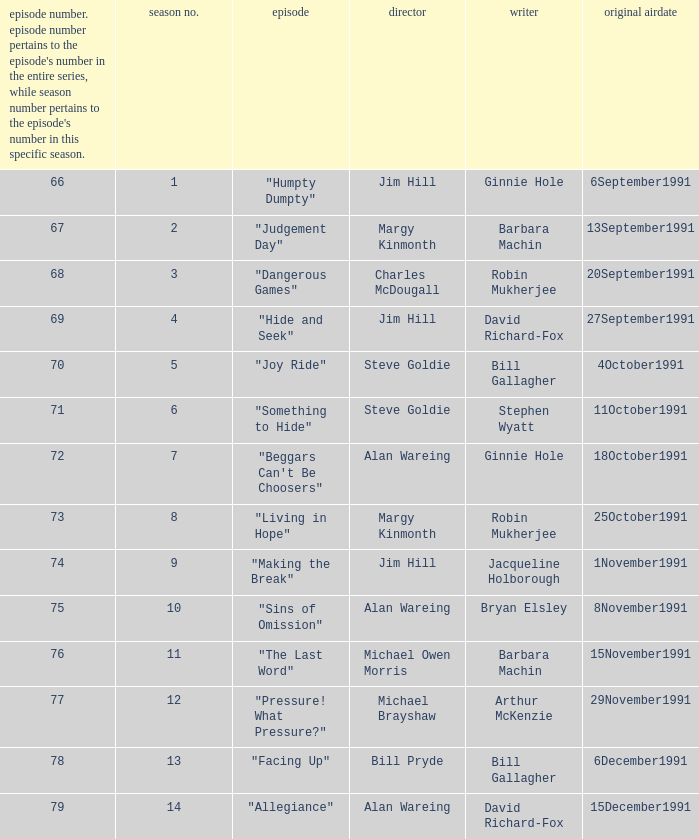Name the least series number for episode number being 78 13.0. 